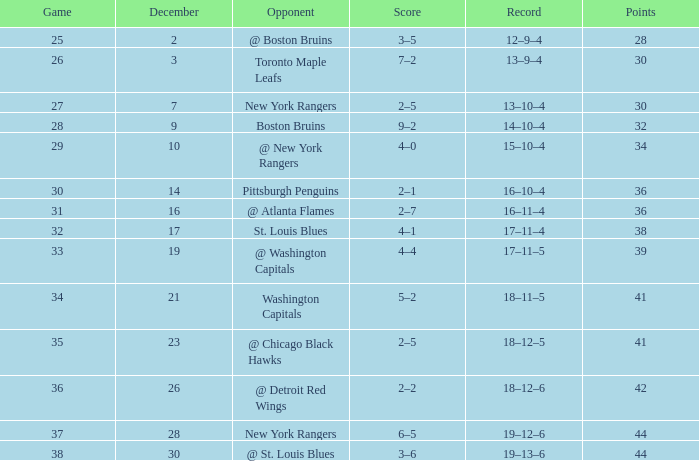Which game has a 14-10-4 record and a point total under 32? None. 